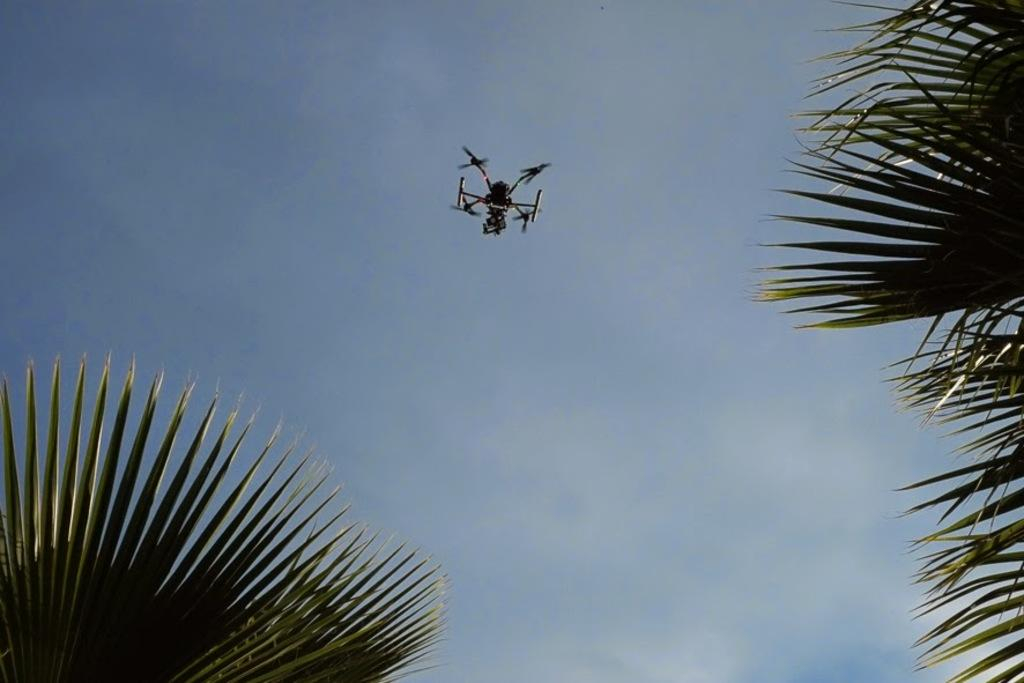What type of vegetation can be seen in the image? There are green leaves in the image. How was the image likely captured? The image appears to be taken from a flying camera. What part of the natural environment is visible in the image? The sky is visible in the image. What can be observed in the sky? Clouds are present in the sky. How many visitors can be seen using a comb in the image? There are no visitors or combs present in the image. What type of passenger is visible in the image? There are no passengers visible in the image. 